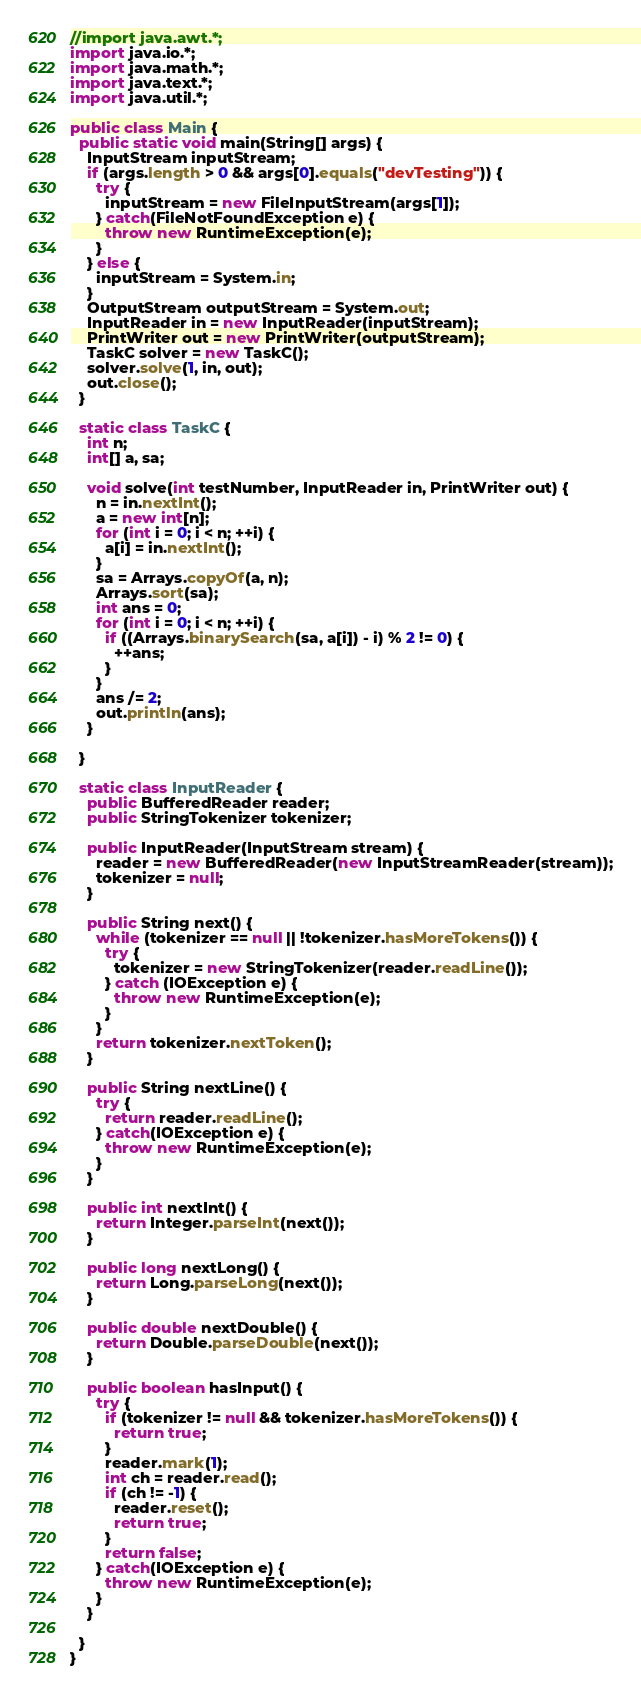Convert code to text. <code><loc_0><loc_0><loc_500><loc_500><_Java_>//import java.awt.*;
import java.io.*;
import java.math.*;
import java.text.*;
import java.util.*;

public class Main {
  public static void main(String[] args) {
    InputStream inputStream;
    if (args.length > 0 && args[0].equals("devTesting")) {
      try {
        inputStream = new FileInputStream(args[1]);
      } catch(FileNotFoundException e) {
        throw new RuntimeException(e);
      }
    } else {
      inputStream = System.in;
    }
    OutputStream outputStream = System.out;
    InputReader in = new InputReader(inputStream);
    PrintWriter out = new PrintWriter(outputStream);
    TaskC solver = new TaskC();
    solver.solve(1, in, out);
    out.close();
  }
  
  static class TaskC {
    int n;
    int[] a, sa;
    
    void solve(int testNumber, InputReader in, PrintWriter out) {
      n = in.nextInt();
      a = new int[n];
      for (int i = 0; i < n; ++i) {
        a[i] = in.nextInt();
      }
      sa = Arrays.copyOf(a, n);
      Arrays.sort(sa);
      int ans = 0;
      for (int i = 0; i < n; ++i) {
        if ((Arrays.binarySearch(sa, a[i]) - i) % 2 != 0) {
          ++ans;
        }
      }
      ans /= 2;
      out.println(ans);
    }

  }
      
  static class InputReader {
    public BufferedReader reader;
    public StringTokenizer tokenizer;

    public InputReader(InputStream stream) {
      reader = new BufferedReader(new InputStreamReader(stream));
      tokenizer = null;
    }

    public String next() {
      while (tokenizer == null || !tokenizer.hasMoreTokens()) {
        try {
          tokenizer = new StringTokenizer(reader.readLine());
        } catch (IOException e) {
          throw new RuntimeException(e);
        }
      }
      return tokenizer.nextToken();
    }
    
    public String nextLine() {
      try {
        return reader.readLine();
      } catch(IOException e) {
        throw new RuntimeException(e);
      }
    }

    public int nextInt() {
      return Integer.parseInt(next());
    }

    public long nextLong() {
      return Long.parseLong(next());
    }
    
    public double nextDouble() {
      return Double.parseDouble(next());
    }

    public boolean hasInput() {
      try {
        if (tokenizer != null && tokenizer.hasMoreTokens()) {
          return true;
        }
        reader.mark(1);
        int ch = reader.read();
        if (ch != -1) {
          reader.reset();
          return true;
        }
        return false;
      } catch(IOException e) {
        throw new RuntimeException(e);
      }
    }
    
  }
}
</code> 